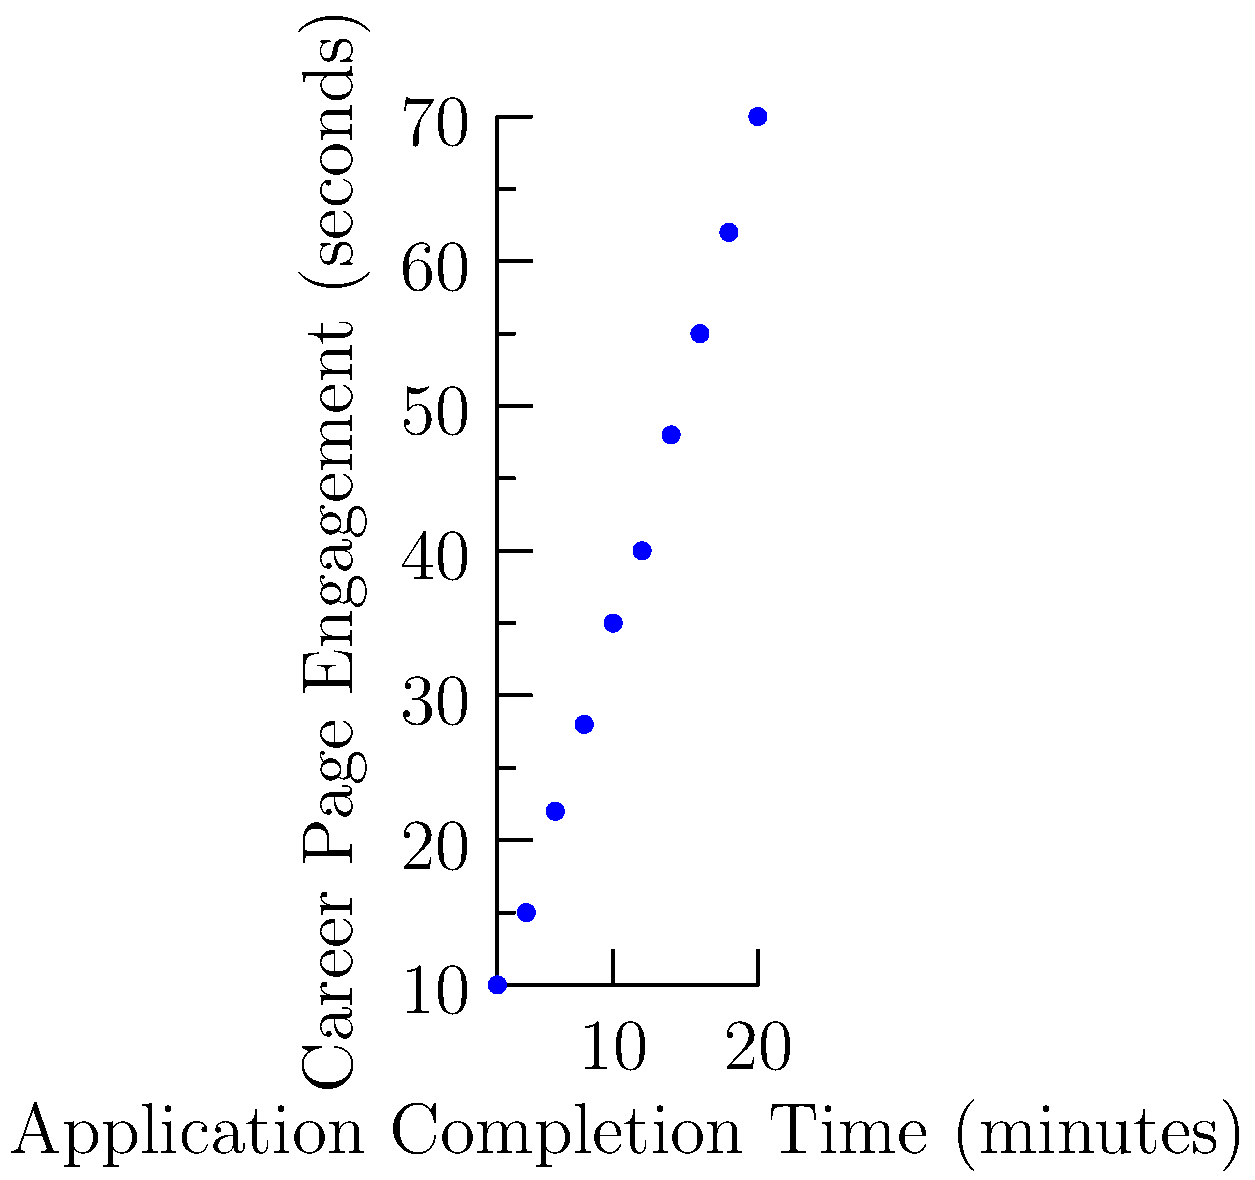As a talent acquisition consultant, you're analyzing the relationship between application completion time and career page engagement. The scatter plot shows data from 10 applicants. What can you conclude about this relationship, and how might this inform your recommendations for optimizing the career page? To analyze the relationship between application completion time and career page engagement, we'll follow these steps:

1. Observe the scatter plot:
   - The x-axis represents application completion time in minutes.
   - The y-axis represents career page engagement in seconds.

2. Identify the pattern:
   - The dots form a clear upward trend from left to right.
   - As application completion time increases, career page engagement also increases.

3. Assess the correlation:
   - The relationship appears to be strong and positive.
   - The red trend line confirms this positive correlation.

4. Interpret the data:
   - Applicants who spend more time completing their applications tend to engage more with the career page.
   - This suggests that a more comprehensive application process may lead to increased engagement.

5. Consider implications:
   - A longer application might provide more opportunities for candidates to explore the career page.
   - However, it's important to balance thoroughness with user experience to avoid drop-offs.

6. Formulate recommendations:
   - Design the career page to encourage exploration during the application process.
   - Integrate relevant content and links within the application to boost engagement.
   - Consider a multi-step application that allows for natural breaks and encourages career page browsing.
   - Ensure that the increased engagement translates to a positive candidate experience and doesn't lead to frustration.

7. Suggest further analysis:
   - Investigate the quality of applications in relation to engagement time.
   - Analyze drop-off rates to find the optimal application length.
   - Conduct user testing to refine the balance between engagement and efficiency.
Answer: Strong positive correlation between application time and engagement; optimize career page with integrated content and multi-step application process to encourage exploration while maintaining positive user experience. 